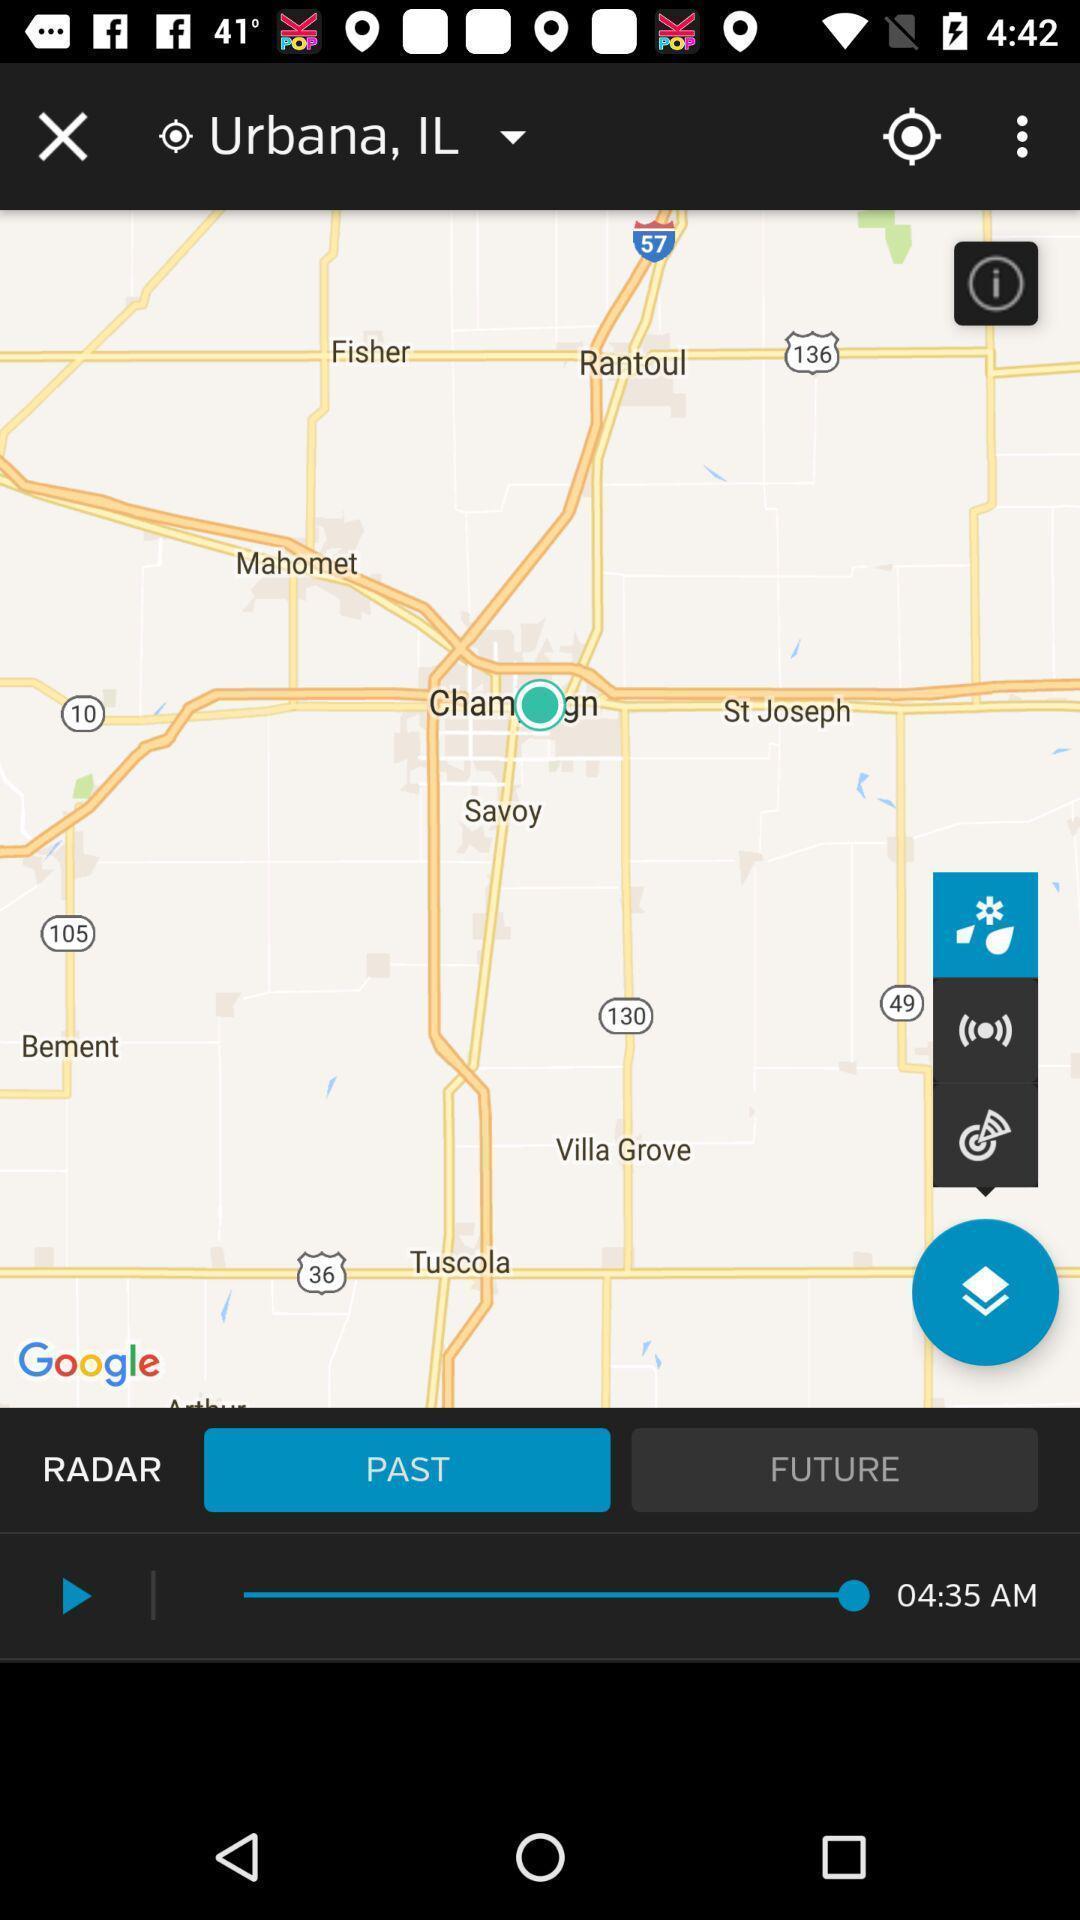Summarize the information in this screenshot. Page showing past radar navigation app. 